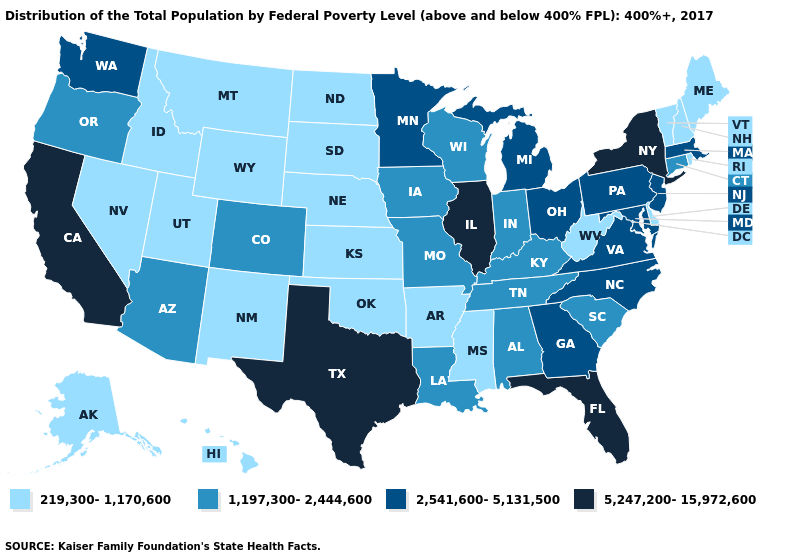Name the states that have a value in the range 1,197,300-2,444,600?
Short answer required. Alabama, Arizona, Colorado, Connecticut, Indiana, Iowa, Kentucky, Louisiana, Missouri, Oregon, South Carolina, Tennessee, Wisconsin. Name the states that have a value in the range 219,300-1,170,600?
Answer briefly. Alaska, Arkansas, Delaware, Hawaii, Idaho, Kansas, Maine, Mississippi, Montana, Nebraska, Nevada, New Hampshire, New Mexico, North Dakota, Oklahoma, Rhode Island, South Dakota, Utah, Vermont, West Virginia, Wyoming. Among the states that border New Mexico , does Texas have the highest value?
Quick response, please. Yes. What is the highest value in the USA?
Keep it brief. 5,247,200-15,972,600. Among the states that border Connecticut , which have the lowest value?
Be succinct. Rhode Island. How many symbols are there in the legend?
Short answer required. 4. Does Nebraska have a higher value than Iowa?
Keep it brief. No. Among the states that border Maryland , does Pennsylvania have the lowest value?
Short answer required. No. Which states have the lowest value in the MidWest?
Keep it brief. Kansas, Nebraska, North Dakota, South Dakota. Which states have the lowest value in the South?
Concise answer only. Arkansas, Delaware, Mississippi, Oklahoma, West Virginia. What is the lowest value in the USA?
Concise answer only. 219,300-1,170,600. Does Wisconsin have the highest value in the USA?
Write a very short answer. No. What is the value of Wisconsin?
Answer briefly. 1,197,300-2,444,600. What is the value of Wyoming?
Be succinct. 219,300-1,170,600. 